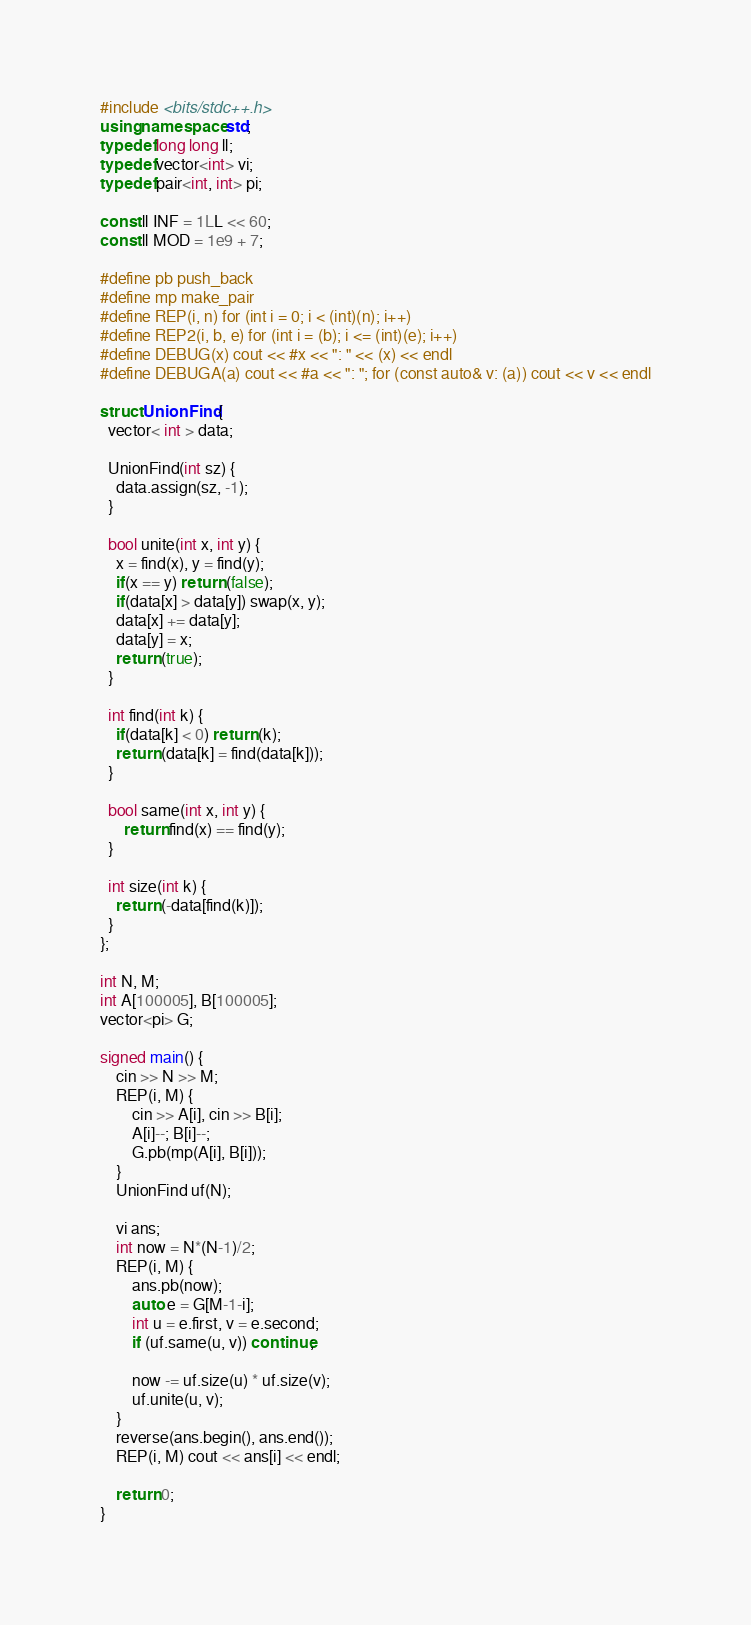<code> <loc_0><loc_0><loc_500><loc_500><_C++_>#include <bits/stdc++.h>
using namespace std;
typedef long long ll;
typedef vector<int> vi;
typedef pair<int, int> pi;

const ll INF = 1LL << 60;
const ll MOD = 1e9 + 7;

#define pb push_back
#define mp make_pair
#define REP(i, n) for (int i = 0; i < (int)(n); i++)
#define REP2(i, b, e) for (int i = (b); i <= (int)(e); i++)
#define DEBUG(x) cout << #x << ": " << (x) << endl
#define DEBUGA(a) cout << #a << ": "; for (const auto& v: (a)) cout << v << endl

struct UnionFind {
  vector< int > data;

  UnionFind(int sz) {
    data.assign(sz, -1);
  }

  bool unite(int x, int y) {
    x = find(x), y = find(y);
    if(x == y) return (false);
    if(data[x] > data[y]) swap(x, y);
    data[x] += data[y];
    data[y] = x;
    return (true);
  }

  int find(int k) {
    if(data[k] < 0) return (k);
    return (data[k] = find(data[k]));
  }

  bool same(int x, int y) {
      return find(x) == find(y);
  }

  int size(int k) {
    return (-data[find(k)]);
  }
};

int N, M;
int A[100005], B[100005];
vector<pi> G;

signed main() {
    cin >> N >> M;
    REP(i, M) {
        cin >> A[i], cin >> B[i];
        A[i]--; B[i]--;
        G.pb(mp(A[i], B[i]));
    }
    UnionFind uf(N);

    vi ans;
    int now = N*(N-1)/2;
    REP(i, M) {
        ans.pb(now);
        auto e = G[M-1-i];
        int u = e.first, v = e.second;
        if (uf.same(u, v)) continue;

        now -= uf.size(u) * uf.size(v);
        uf.unite(u, v);
    }
    reverse(ans.begin(), ans.end());
    REP(i, M) cout << ans[i] << endl;

    return 0;
}
</code> 